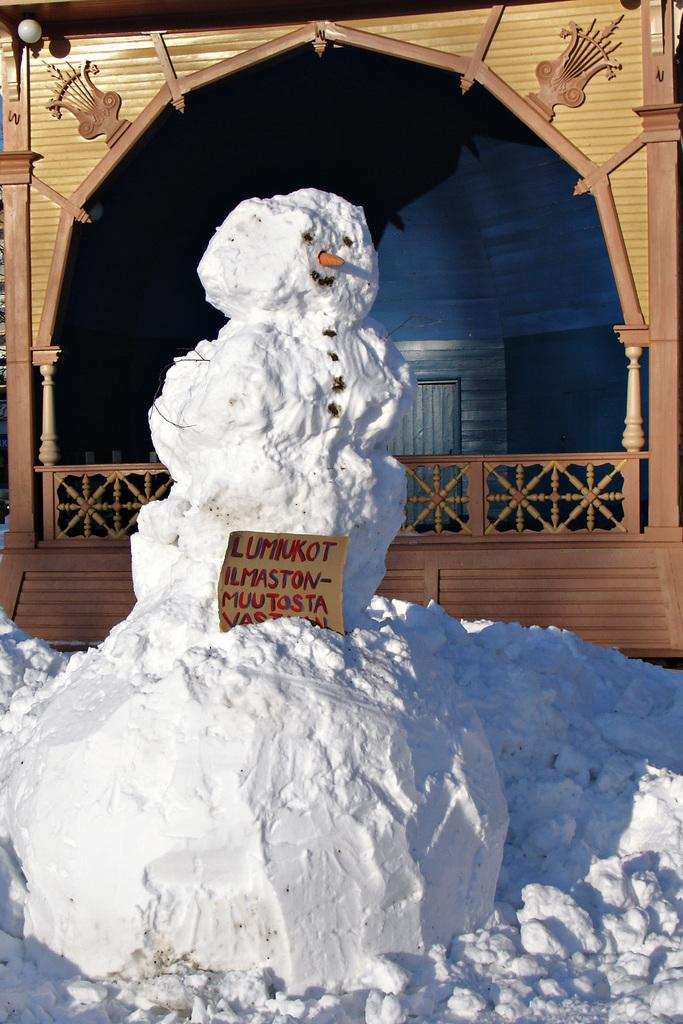What is the main subject of the image? There is a statue made of snow in the image. What is unique about the snow statue? There is text written on the snow statue. What can be seen in the background of the image? There is a shelter in the background of the image. What type of oranges can be seen hanging from the snow statue? There are no oranges present in the image; the statue is made of snow and has text written on it. 